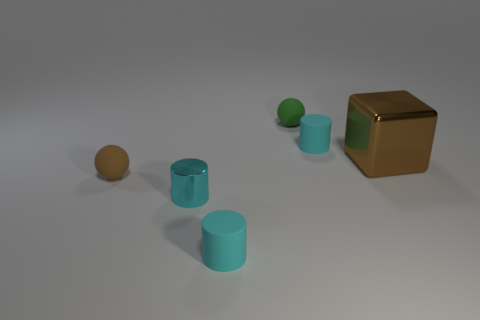What number of tiny things are the same color as the shiny block?
Provide a short and direct response. 1. Are there any other things that have the same shape as the large brown object?
Your answer should be compact. No. Does the green rubber thing have the same shape as the small brown thing?
Keep it short and to the point. Yes. What number of metallic objects are either big blocks or cyan cylinders?
Offer a very short reply. 2. What is the material of the thing that is the same color as the shiny block?
Make the answer very short. Rubber. Is the brown matte ball the same size as the green matte thing?
Your response must be concise. Yes. How many objects are gray cylinders or small spheres that are behind the tiny brown rubber sphere?
Your answer should be compact. 1. There is a brown ball that is the same size as the green sphere; what is it made of?
Give a very brief answer. Rubber. What is the tiny thing that is both in front of the brown cube and on the right side of the cyan metallic object made of?
Provide a succinct answer. Rubber. There is a small rubber cylinder in front of the brown cube; are there any balls on the left side of it?
Offer a terse response. Yes. 